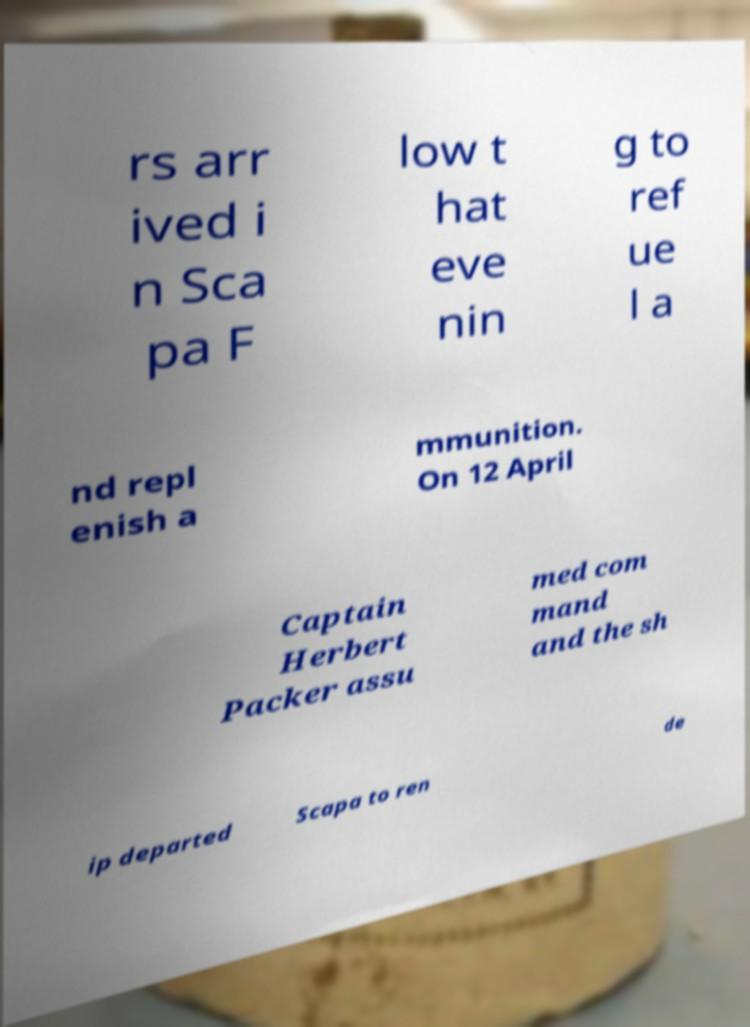Could you assist in decoding the text presented in this image and type it out clearly? rs arr ived i n Sca pa F low t hat eve nin g to ref ue l a nd repl enish a mmunition. On 12 April Captain Herbert Packer assu med com mand and the sh ip departed Scapa to ren de 